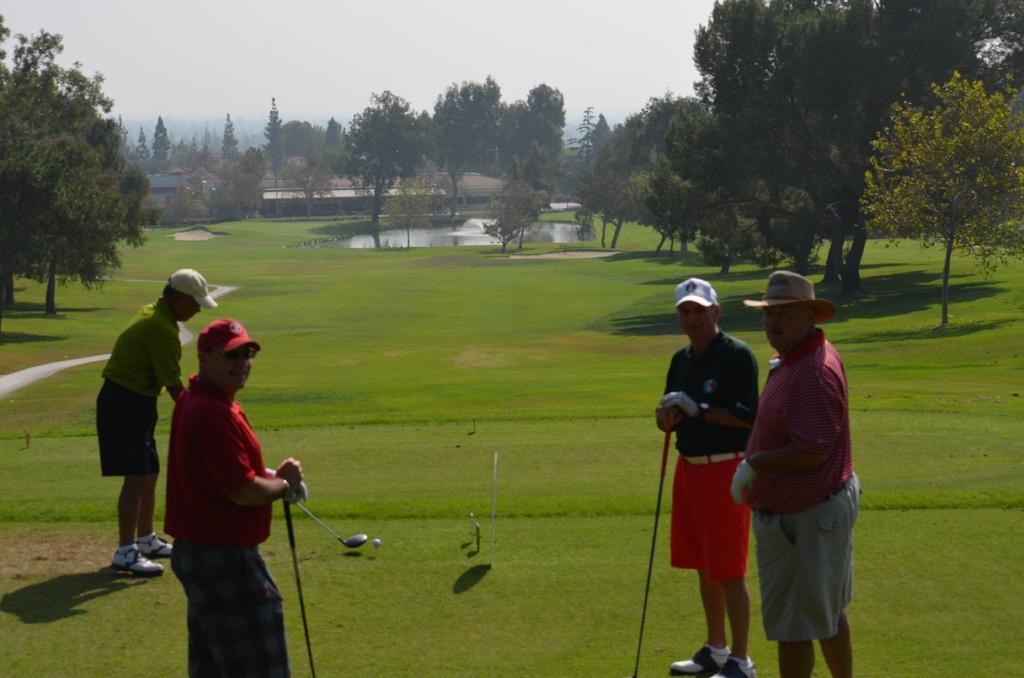In one or two sentences, can you explain what this image depicts? In this image four persons are standing on the grassland. Left side a person wearing a red shirt is holding a stick in his hand. He is wearing goggles and cap. Behind him there is a person wearing a cap. A ball is on the grassland. Right side there are two persons standing on the grassland. They are wearing caps. Background there are few trees and houses. Top of image there is sky. Middle of image there is water beside grassland. 